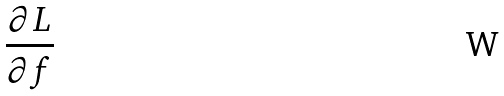Convert formula to latex. <formula><loc_0><loc_0><loc_500><loc_500>\frac { \partial L } { \partial f }</formula> 